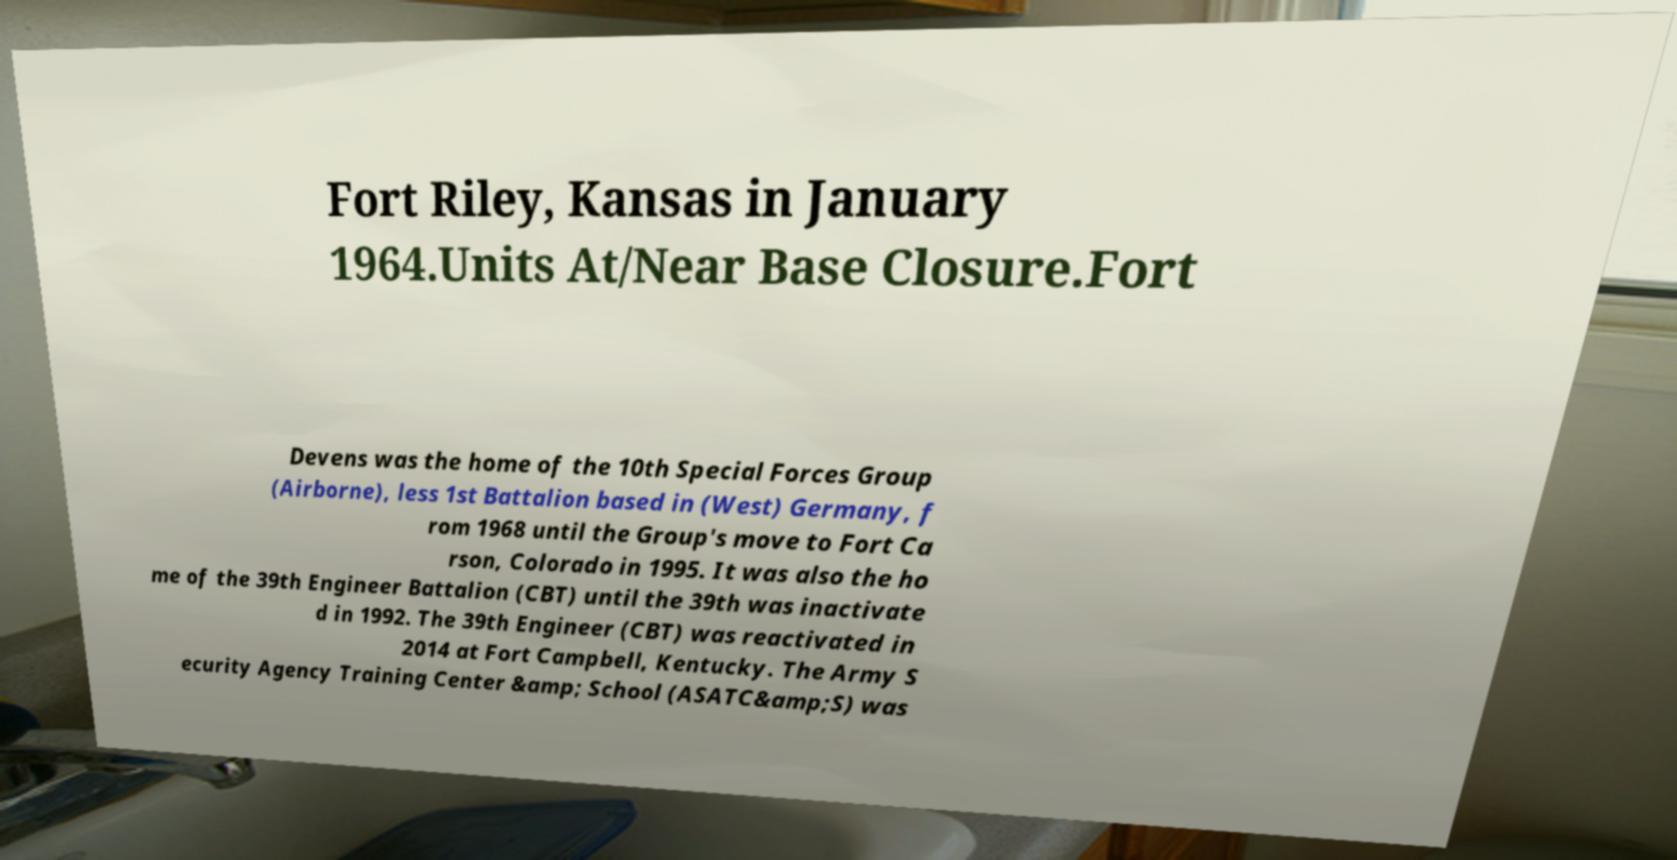There's text embedded in this image that I need extracted. Can you transcribe it verbatim? Fort Riley, Kansas in January 1964.Units At/Near Base Closure.Fort Devens was the home of the 10th Special Forces Group (Airborne), less 1st Battalion based in (West) Germany, f rom 1968 until the Group's move to Fort Ca rson, Colorado in 1995. It was also the ho me of the 39th Engineer Battalion (CBT) until the 39th was inactivate d in 1992. The 39th Engineer (CBT) was reactivated in 2014 at Fort Campbell, Kentucky. The Army S ecurity Agency Training Center &amp; School (ASATC&amp;S) was 